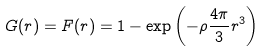<formula> <loc_0><loc_0><loc_500><loc_500>G ( r ) = F ( r ) = 1 - \exp \left ( - \rho \frac { 4 \pi } { 3 } r ^ { 3 } \right )</formula> 